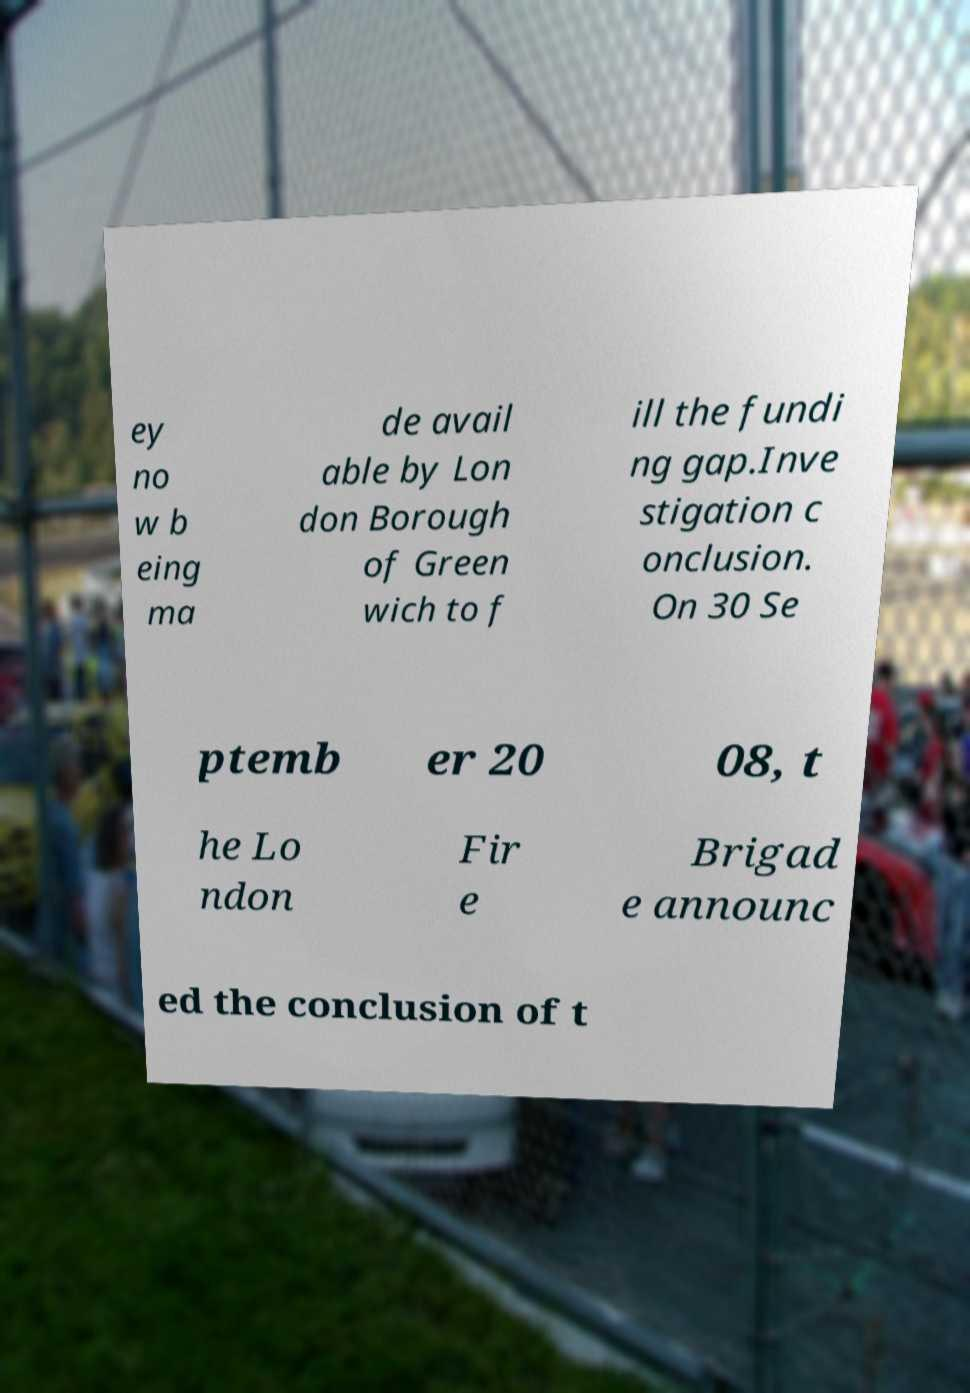Please identify and transcribe the text found in this image. ey no w b eing ma de avail able by Lon don Borough of Green wich to f ill the fundi ng gap.Inve stigation c onclusion. On 30 Se ptemb er 20 08, t he Lo ndon Fir e Brigad e announc ed the conclusion of t 